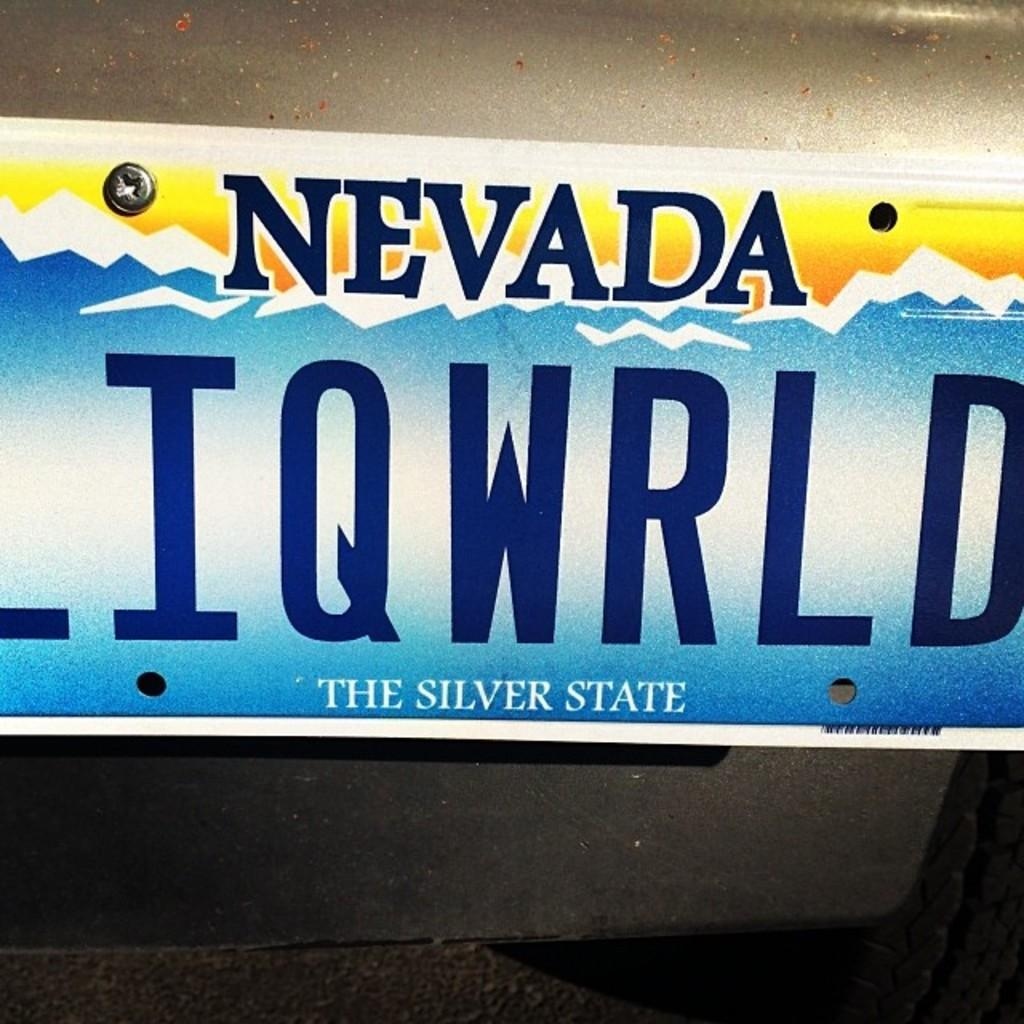<image>
Create a compact narrative representing the image presented. A NEVADA license plate with the last six letters IQWRLD. 